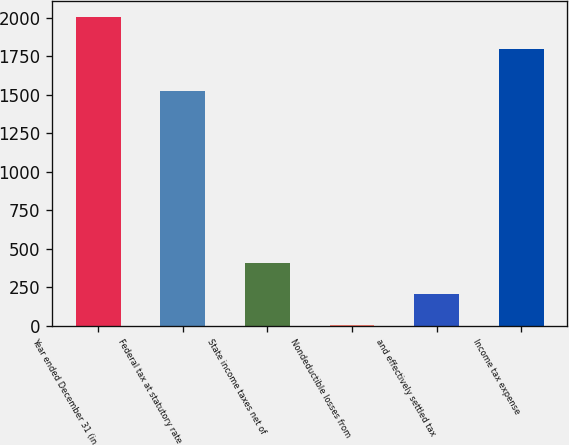<chart> <loc_0><loc_0><loc_500><loc_500><bar_chart><fcel>Year ended December 31 (in<fcel>Federal tax at statutory rate<fcel>State income taxes net of<fcel>Nondeductible losses from<fcel>and effectively settled tax<fcel>Income tax expense<nl><fcel>2007<fcel>1522<fcel>403.8<fcel>3<fcel>203.4<fcel>1800<nl></chart> 